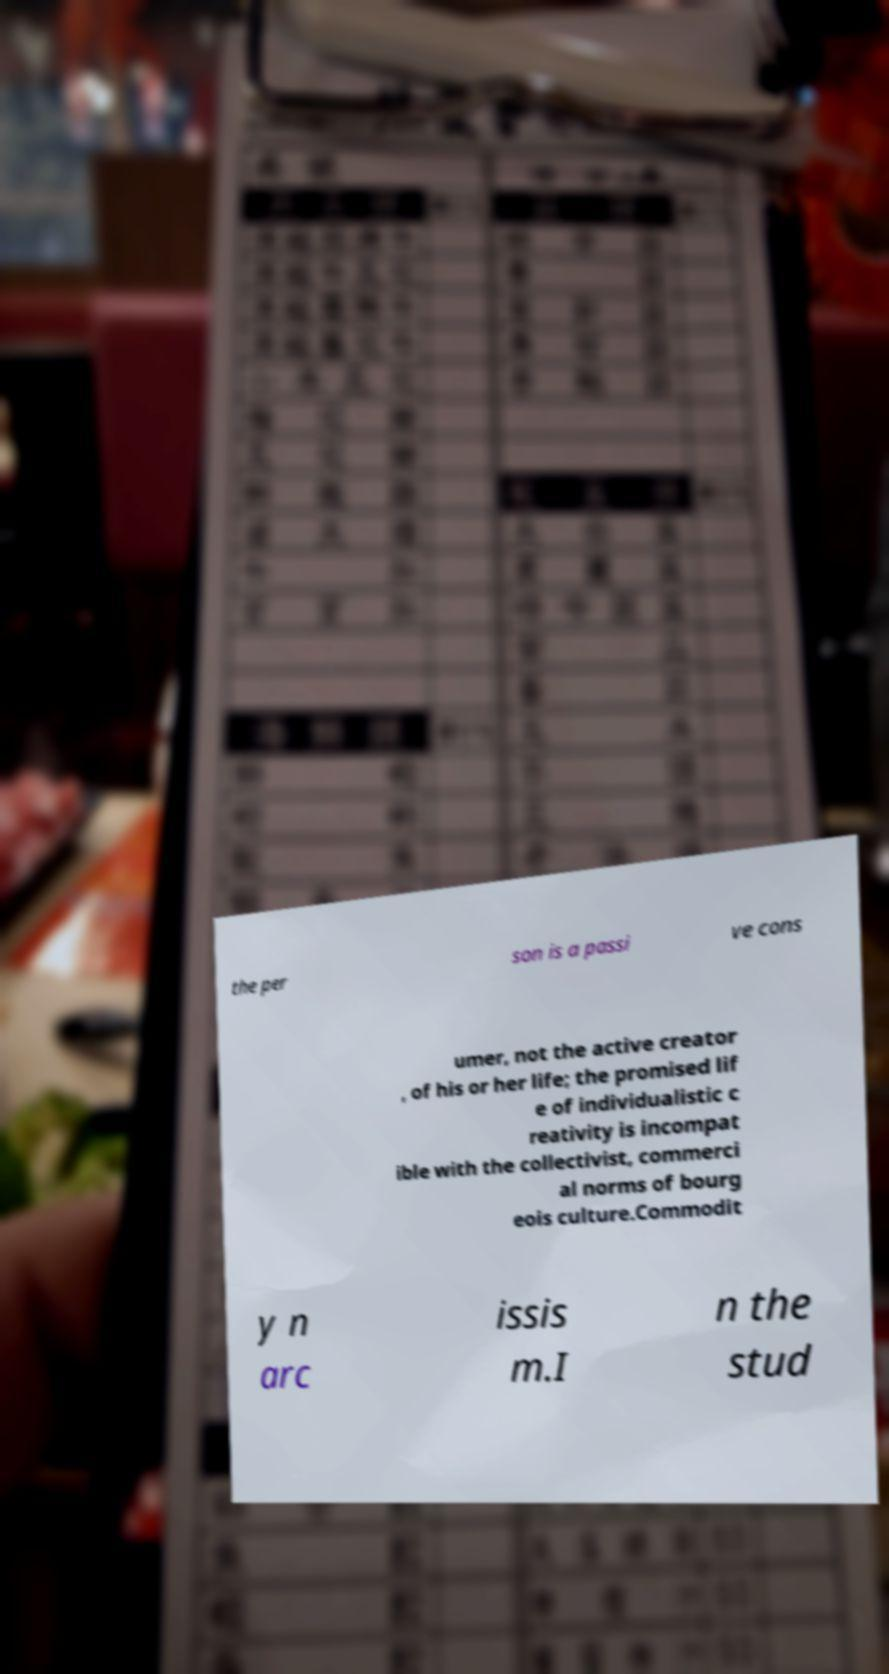Can you accurately transcribe the text from the provided image for me? the per son is a passi ve cons umer, not the active creator , of his or her life; the promised lif e of individualistic c reativity is incompat ible with the collectivist, commerci al norms of bourg eois culture.Commodit y n arc issis m.I n the stud 